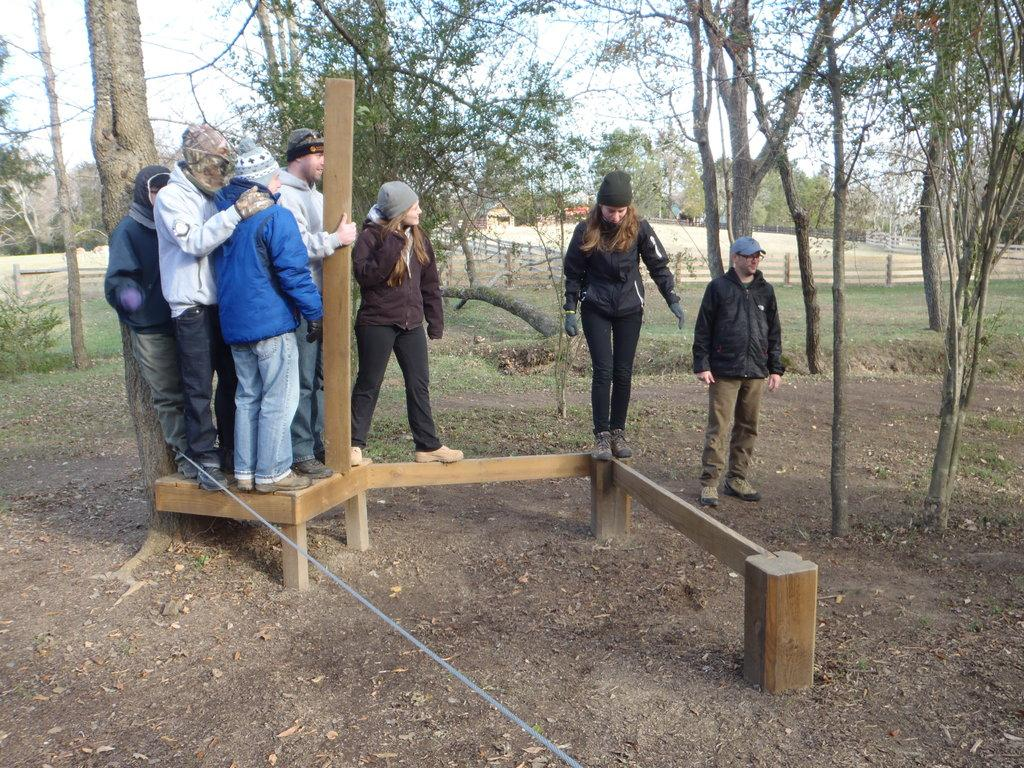What are the people in the image wearing? The people in the image are wearing clothes. What can be seen in the middle of the image? There is a wooden stand in the middle of the image. What is visible in the background of the image? There are trees and a fence in the background of the image. What type of vessel can be seen sailing in the background of the image? There is no vessel present in the image; it only features people, a wooden stand, trees, and a fence in the background. 